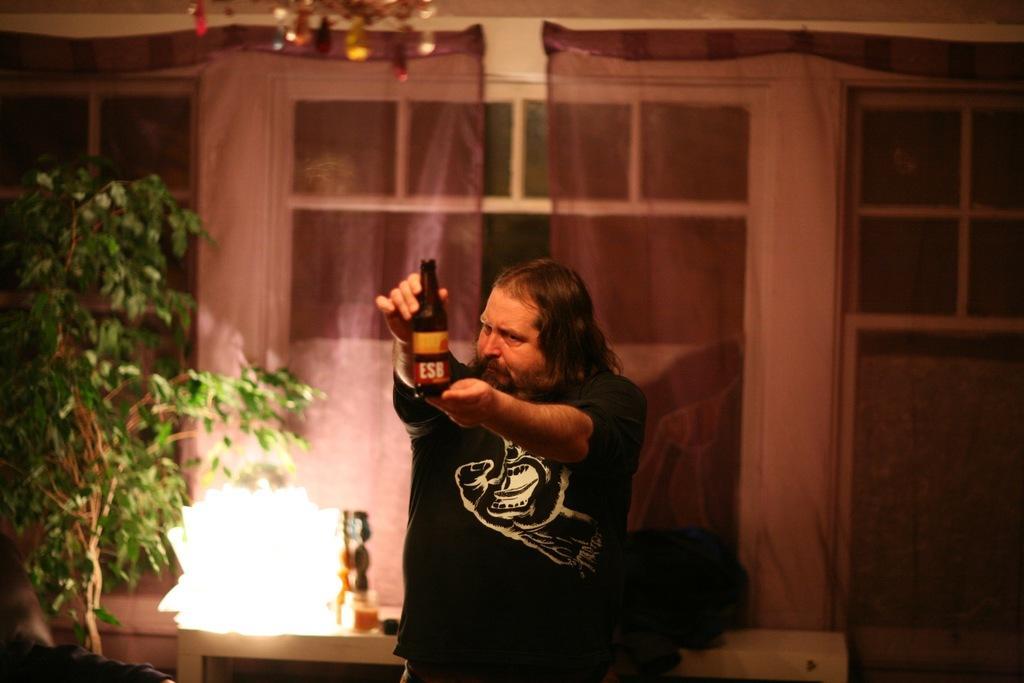Describe this image in one or two sentences. In this image there is a person holding the bottle. Behind him there is a table. On top of it there are a few objects. On the left side of the image there is a plant. In the background of the image there are glass windows. There are curtains. On top of the image there is a decorative item. 